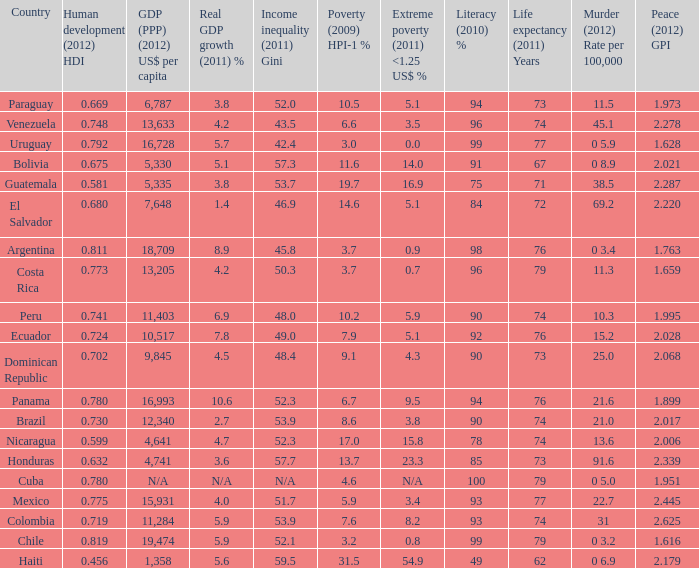What is the sum of poverty (2009) HPI-1 % when the GDP (PPP) (2012) US$ per capita of 11,284? 1.0. 